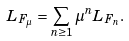Convert formula to latex. <formula><loc_0><loc_0><loc_500><loc_500>L _ { F _ { \mu } } = \sum _ { n \geq 1 } \mu ^ { n } L _ { F _ { n } } .</formula> 